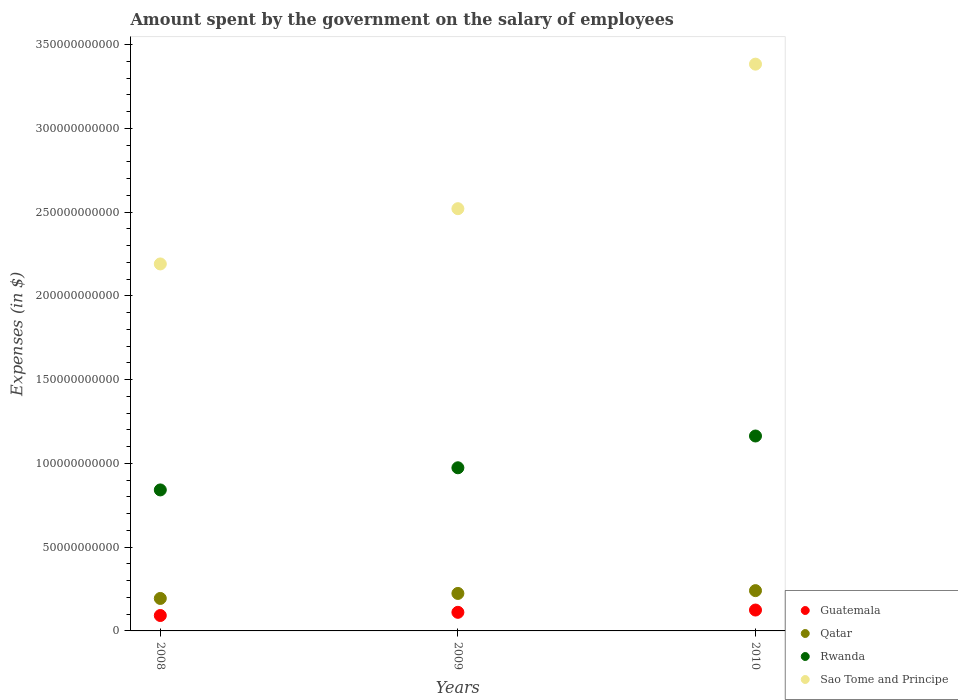How many different coloured dotlines are there?
Offer a very short reply. 4. Is the number of dotlines equal to the number of legend labels?
Make the answer very short. Yes. What is the amount spent on the salary of employees by the government in Guatemala in 2008?
Your response must be concise. 9.20e+09. Across all years, what is the maximum amount spent on the salary of employees by the government in Guatemala?
Offer a very short reply. 1.25e+1. Across all years, what is the minimum amount spent on the salary of employees by the government in Rwanda?
Provide a short and direct response. 8.42e+1. What is the total amount spent on the salary of employees by the government in Rwanda in the graph?
Your answer should be very brief. 2.98e+11. What is the difference between the amount spent on the salary of employees by the government in Guatemala in 2008 and that in 2009?
Give a very brief answer. -1.90e+09. What is the difference between the amount spent on the salary of employees by the government in Sao Tome and Principe in 2008 and the amount spent on the salary of employees by the government in Qatar in 2009?
Provide a succinct answer. 1.97e+11. What is the average amount spent on the salary of employees by the government in Qatar per year?
Provide a succinct answer. 2.19e+1. In the year 2008, what is the difference between the amount spent on the salary of employees by the government in Guatemala and amount spent on the salary of employees by the government in Qatar?
Give a very brief answer. -1.02e+1. In how many years, is the amount spent on the salary of employees by the government in Guatemala greater than 110000000000 $?
Ensure brevity in your answer.  0. What is the ratio of the amount spent on the salary of employees by the government in Guatemala in 2008 to that in 2009?
Offer a terse response. 0.83. Is the amount spent on the salary of employees by the government in Sao Tome and Principe in 2008 less than that in 2009?
Ensure brevity in your answer.  Yes. What is the difference between the highest and the second highest amount spent on the salary of employees by the government in Rwanda?
Offer a terse response. 1.90e+1. What is the difference between the highest and the lowest amount spent on the salary of employees by the government in Sao Tome and Principe?
Your response must be concise. 1.19e+11. Is it the case that in every year, the sum of the amount spent on the salary of employees by the government in Guatemala and amount spent on the salary of employees by the government in Rwanda  is greater than the sum of amount spent on the salary of employees by the government in Sao Tome and Principe and amount spent on the salary of employees by the government in Qatar?
Make the answer very short. Yes. Is it the case that in every year, the sum of the amount spent on the salary of employees by the government in Sao Tome and Principe and amount spent on the salary of employees by the government in Guatemala  is greater than the amount spent on the salary of employees by the government in Rwanda?
Your answer should be very brief. Yes. Is the amount spent on the salary of employees by the government in Rwanda strictly greater than the amount spent on the salary of employees by the government in Qatar over the years?
Your response must be concise. Yes. How many dotlines are there?
Keep it short and to the point. 4. Are the values on the major ticks of Y-axis written in scientific E-notation?
Offer a very short reply. No. Does the graph contain any zero values?
Your response must be concise. No. Does the graph contain grids?
Your answer should be very brief. No. Where does the legend appear in the graph?
Give a very brief answer. Bottom right. How many legend labels are there?
Your answer should be very brief. 4. How are the legend labels stacked?
Your response must be concise. Vertical. What is the title of the graph?
Keep it short and to the point. Amount spent by the government on the salary of employees. What is the label or title of the Y-axis?
Your response must be concise. Expenses (in $). What is the Expenses (in $) of Guatemala in 2008?
Your answer should be compact. 9.20e+09. What is the Expenses (in $) in Qatar in 2008?
Offer a terse response. 1.94e+1. What is the Expenses (in $) of Rwanda in 2008?
Make the answer very short. 8.42e+1. What is the Expenses (in $) in Sao Tome and Principe in 2008?
Your answer should be very brief. 2.19e+11. What is the Expenses (in $) of Guatemala in 2009?
Provide a succinct answer. 1.11e+1. What is the Expenses (in $) in Qatar in 2009?
Offer a terse response. 2.24e+1. What is the Expenses (in $) of Rwanda in 2009?
Offer a very short reply. 9.74e+1. What is the Expenses (in $) of Sao Tome and Principe in 2009?
Provide a succinct answer. 2.52e+11. What is the Expenses (in $) of Guatemala in 2010?
Your answer should be compact. 1.25e+1. What is the Expenses (in $) in Qatar in 2010?
Your answer should be very brief. 2.41e+1. What is the Expenses (in $) of Rwanda in 2010?
Your answer should be very brief. 1.16e+11. What is the Expenses (in $) of Sao Tome and Principe in 2010?
Your answer should be compact. 3.38e+11. Across all years, what is the maximum Expenses (in $) of Guatemala?
Ensure brevity in your answer.  1.25e+1. Across all years, what is the maximum Expenses (in $) in Qatar?
Ensure brevity in your answer.  2.41e+1. Across all years, what is the maximum Expenses (in $) in Rwanda?
Offer a very short reply. 1.16e+11. Across all years, what is the maximum Expenses (in $) in Sao Tome and Principe?
Your answer should be very brief. 3.38e+11. Across all years, what is the minimum Expenses (in $) in Guatemala?
Your answer should be compact. 9.20e+09. Across all years, what is the minimum Expenses (in $) in Qatar?
Provide a short and direct response. 1.94e+1. Across all years, what is the minimum Expenses (in $) of Rwanda?
Provide a succinct answer. 8.42e+1. Across all years, what is the minimum Expenses (in $) of Sao Tome and Principe?
Offer a terse response. 2.19e+11. What is the total Expenses (in $) of Guatemala in the graph?
Your answer should be very brief. 3.28e+1. What is the total Expenses (in $) of Qatar in the graph?
Provide a succinct answer. 6.58e+1. What is the total Expenses (in $) in Rwanda in the graph?
Your answer should be very brief. 2.98e+11. What is the total Expenses (in $) of Sao Tome and Principe in the graph?
Your answer should be very brief. 8.10e+11. What is the difference between the Expenses (in $) of Guatemala in 2008 and that in 2009?
Your response must be concise. -1.90e+09. What is the difference between the Expenses (in $) in Qatar in 2008 and that in 2009?
Your response must be concise. -2.99e+09. What is the difference between the Expenses (in $) of Rwanda in 2008 and that in 2009?
Offer a very short reply. -1.32e+1. What is the difference between the Expenses (in $) of Sao Tome and Principe in 2008 and that in 2009?
Give a very brief answer. -3.30e+1. What is the difference between the Expenses (in $) of Guatemala in 2008 and that in 2010?
Keep it short and to the point. -3.26e+09. What is the difference between the Expenses (in $) of Qatar in 2008 and that in 2010?
Your response must be concise. -4.67e+09. What is the difference between the Expenses (in $) in Rwanda in 2008 and that in 2010?
Provide a succinct answer. -3.22e+1. What is the difference between the Expenses (in $) of Sao Tome and Principe in 2008 and that in 2010?
Make the answer very short. -1.19e+11. What is the difference between the Expenses (in $) in Guatemala in 2009 and that in 2010?
Provide a short and direct response. -1.36e+09. What is the difference between the Expenses (in $) of Qatar in 2009 and that in 2010?
Give a very brief answer. -1.67e+09. What is the difference between the Expenses (in $) in Rwanda in 2009 and that in 2010?
Offer a very short reply. -1.90e+1. What is the difference between the Expenses (in $) of Sao Tome and Principe in 2009 and that in 2010?
Your answer should be very brief. -8.63e+1. What is the difference between the Expenses (in $) of Guatemala in 2008 and the Expenses (in $) of Qatar in 2009?
Your answer should be compact. -1.32e+1. What is the difference between the Expenses (in $) of Guatemala in 2008 and the Expenses (in $) of Rwanda in 2009?
Provide a short and direct response. -8.82e+1. What is the difference between the Expenses (in $) in Guatemala in 2008 and the Expenses (in $) in Sao Tome and Principe in 2009?
Make the answer very short. -2.43e+11. What is the difference between the Expenses (in $) in Qatar in 2008 and the Expenses (in $) in Rwanda in 2009?
Your response must be concise. -7.80e+1. What is the difference between the Expenses (in $) in Qatar in 2008 and the Expenses (in $) in Sao Tome and Principe in 2009?
Provide a short and direct response. -2.33e+11. What is the difference between the Expenses (in $) of Rwanda in 2008 and the Expenses (in $) of Sao Tome and Principe in 2009?
Make the answer very short. -1.68e+11. What is the difference between the Expenses (in $) in Guatemala in 2008 and the Expenses (in $) in Qatar in 2010?
Keep it short and to the point. -1.49e+1. What is the difference between the Expenses (in $) of Guatemala in 2008 and the Expenses (in $) of Rwanda in 2010?
Ensure brevity in your answer.  -1.07e+11. What is the difference between the Expenses (in $) of Guatemala in 2008 and the Expenses (in $) of Sao Tome and Principe in 2010?
Ensure brevity in your answer.  -3.29e+11. What is the difference between the Expenses (in $) in Qatar in 2008 and the Expenses (in $) in Rwanda in 2010?
Provide a short and direct response. -9.70e+1. What is the difference between the Expenses (in $) in Qatar in 2008 and the Expenses (in $) in Sao Tome and Principe in 2010?
Provide a succinct answer. -3.19e+11. What is the difference between the Expenses (in $) in Rwanda in 2008 and the Expenses (in $) in Sao Tome and Principe in 2010?
Provide a short and direct response. -2.54e+11. What is the difference between the Expenses (in $) in Guatemala in 2009 and the Expenses (in $) in Qatar in 2010?
Make the answer very short. -1.30e+1. What is the difference between the Expenses (in $) of Guatemala in 2009 and the Expenses (in $) of Rwanda in 2010?
Your answer should be very brief. -1.05e+11. What is the difference between the Expenses (in $) of Guatemala in 2009 and the Expenses (in $) of Sao Tome and Principe in 2010?
Provide a succinct answer. -3.27e+11. What is the difference between the Expenses (in $) of Qatar in 2009 and the Expenses (in $) of Rwanda in 2010?
Your response must be concise. -9.40e+1. What is the difference between the Expenses (in $) in Qatar in 2009 and the Expenses (in $) in Sao Tome and Principe in 2010?
Keep it short and to the point. -3.16e+11. What is the difference between the Expenses (in $) of Rwanda in 2009 and the Expenses (in $) of Sao Tome and Principe in 2010?
Keep it short and to the point. -2.41e+11. What is the average Expenses (in $) in Guatemala per year?
Offer a very short reply. 1.09e+1. What is the average Expenses (in $) in Qatar per year?
Offer a terse response. 2.19e+1. What is the average Expenses (in $) in Rwanda per year?
Give a very brief answer. 9.93e+1. What is the average Expenses (in $) in Sao Tome and Principe per year?
Offer a very short reply. 2.70e+11. In the year 2008, what is the difference between the Expenses (in $) in Guatemala and Expenses (in $) in Qatar?
Provide a succinct answer. -1.02e+1. In the year 2008, what is the difference between the Expenses (in $) in Guatemala and Expenses (in $) in Rwanda?
Make the answer very short. -7.50e+1. In the year 2008, what is the difference between the Expenses (in $) of Guatemala and Expenses (in $) of Sao Tome and Principe?
Your response must be concise. -2.10e+11. In the year 2008, what is the difference between the Expenses (in $) in Qatar and Expenses (in $) in Rwanda?
Your answer should be compact. -6.48e+1. In the year 2008, what is the difference between the Expenses (in $) of Qatar and Expenses (in $) of Sao Tome and Principe?
Give a very brief answer. -2.00e+11. In the year 2008, what is the difference between the Expenses (in $) of Rwanda and Expenses (in $) of Sao Tome and Principe?
Ensure brevity in your answer.  -1.35e+11. In the year 2009, what is the difference between the Expenses (in $) in Guatemala and Expenses (in $) in Qatar?
Your response must be concise. -1.13e+1. In the year 2009, what is the difference between the Expenses (in $) in Guatemala and Expenses (in $) in Rwanda?
Provide a succinct answer. -8.63e+1. In the year 2009, what is the difference between the Expenses (in $) of Guatemala and Expenses (in $) of Sao Tome and Principe?
Offer a terse response. -2.41e+11. In the year 2009, what is the difference between the Expenses (in $) of Qatar and Expenses (in $) of Rwanda?
Make the answer very short. -7.50e+1. In the year 2009, what is the difference between the Expenses (in $) in Qatar and Expenses (in $) in Sao Tome and Principe?
Give a very brief answer. -2.30e+11. In the year 2009, what is the difference between the Expenses (in $) of Rwanda and Expenses (in $) of Sao Tome and Principe?
Offer a very short reply. -1.55e+11. In the year 2010, what is the difference between the Expenses (in $) of Guatemala and Expenses (in $) of Qatar?
Keep it short and to the point. -1.16e+1. In the year 2010, what is the difference between the Expenses (in $) in Guatemala and Expenses (in $) in Rwanda?
Give a very brief answer. -1.04e+11. In the year 2010, what is the difference between the Expenses (in $) of Guatemala and Expenses (in $) of Sao Tome and Principe?
Offer a very short reply. -3.26e+11. In the year 2010, what is the difference between the Expenses (in $) of Qatar and Expenses (in $) of Rwanda?
Keep it short and to the point. -9.23e+1. In the year 2010, what is the difference between the Expenses (in $) of Qatar and Expenses (in $) of Sao Tome and Principe?
Your answer should be compact. -3.14e+11. In the year 2010, what is the difference between the Expenses (in $) of Rwanda and Expenses (in $) of Sao Tome and Principe?
Give a very brief answer. -2.22e+11. What is the ratio of the Expenses (in $) in Guatemala in 2008 to that in 2009?
Your answer should be compact. 0.83. What is the ratio of the Expenses (in $) in Qatar in 2008 to that in 2009?
Your answer should be compact. 0.87. What is the ratio of the Expenses (in $) in Rwanda in 2008 to that in 2009?
Offer a terse response. 0.86. What is the ratio of the Expenses (in $) of Sao Tome and Principe in 2008 to that in 2009?
Ensure brevity in your answer.  0.87. What is the ratio of the Expenses (in $) in Guatemala in 2008 to that in 2010?
Offer a very short reply. 0.74. What is the ratio of the Expenses (in $) of Qatar in 2008 to that in 2010?
Offer a very short reply. 0.81. What is the ratio of the Expenses (in $) in Rwanda in 2008 to that in 2010?
Make the answer very short. 0.72. What is the ratio of the Expenses (in $) in Sao Tome and Principe in 2008 to that in 2010?
Ensure brevity in your answer.  0.65. What is the ratio of the Expenses (in $) of Guatemala in 2009 to that in 2010?
Ensure brevity in your answer.  0.89. What is the ratio of the Expenses (in $) of Qatar in 2009 to that in 2010?
Provide a succinct answer. 0.93. What is the ratio of the Expenses (in $) in Rwanda in 2009 to that in 2010?
Ensure brevity in your answer.  0.84. What is the ratio of the Expenses (in $) of Sao Tome and Principe in 2009 to that in 2010?
Make the answer very short. 0.74. What is the difference between the highest and the second highest Expenses (in $) in Guatemala?
Provide a succinct answer. 1.36e+09. What is the difference between the highest and the second highest Expenses (in $) in Qatar?
Ensure brevity in your answer.  1.67e+09. What is the difference between the highest and the second highest Expenses (in $) of Rwanda?
Make the answer very short. 1.90e+1. What is the difference between the highest and the second highest Expenses (in $) of Sao Tome and Principe?
Make the answer very short. 8.63e+1. What is the difference between the highest and the lowest Expenses (in $) in Guatemala?
Your answer should be compact. 3.26e+09. What is the difference between the highest and the lowest Expenses (in $) in Qatar?
Offer a terse response. 4.67e+09. What is the difference between the highest and the lowest Expenses (in $) of Rwanda?
Give a very brief answer. 3.22e+1. What is the difference between the highest and the lowest Expenses (in $) of Sao Tome and Principe?
Make the answer very short. 1.19e+11. 